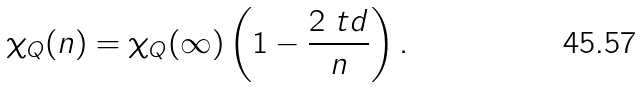<formula> <loc_0><loc_0><loc_500><loc_500>\chi _ { Q } ( n ) = \chi _ { Q } ( \infty ) \left ( 1 - \frac { 2 \ t d } { n } \right ) .</formula> 